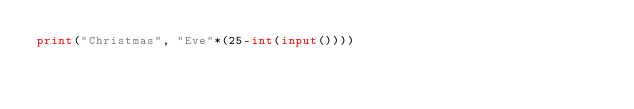Convert code to text. <code><loc_0><loc_0><loc_500><loc_500><_Python_>print("Christmas", "Eve"*(25-int(input())))</code> 